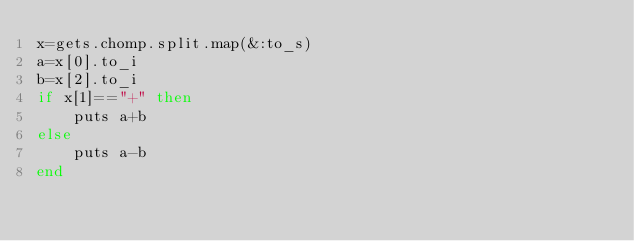Convert code to text. <code><loc_0><loc_0><loc_500><loc_500><_Ruby_>x=gets.chomp.split.map(&:to_s)
a=x[0].to_i
b=x[2].to_i
if x[1]=="+" then
    puts a+b
else
    puts a-b
end</code> 